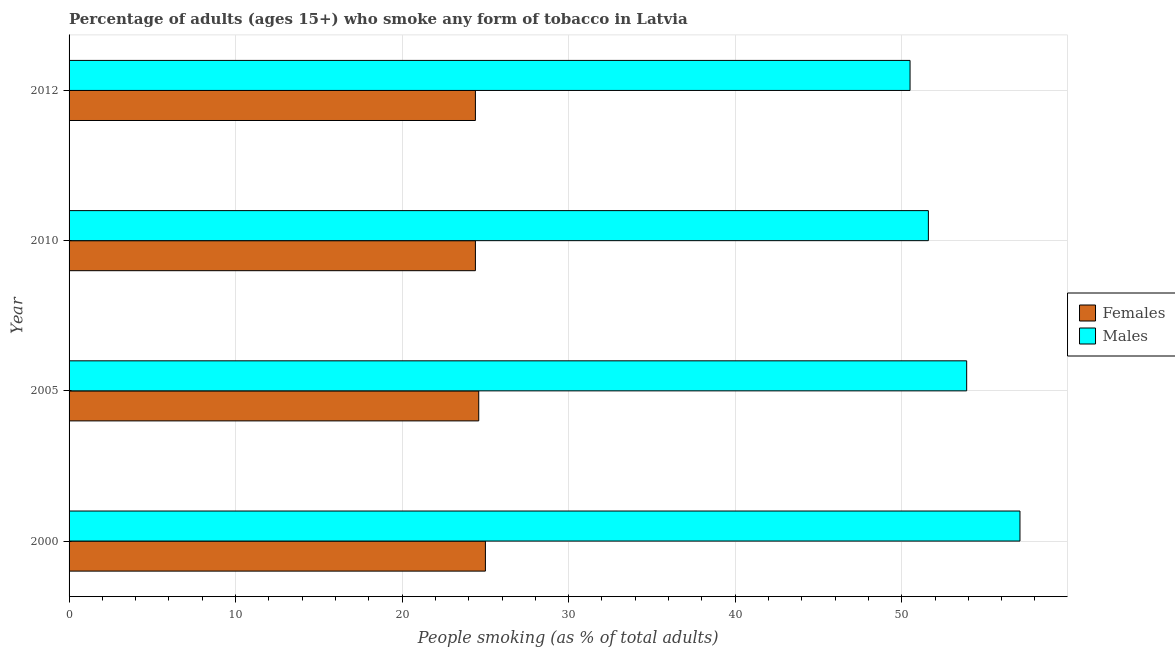How many groups of bars are there?
Your answer should be very brief. 4. Are the number of bars on each tick of the Y-axis equal?
Offer a terse response. Yes. How many bars are there on the 3rd tick from the bottom?
Keep it short and to the point. 2. What is the label of the 4th group of bars from the top?
Make the answer very short. 2000. In how many cases, is the number of bars for a given year not equal to the number of legend labels?
Your response must be concise. 0. What is the percentage of females who smoke in 2005?
Ensure brevity in your answer.  24.6. Across all years, what is the minimum percentage of males who smoke?
Make the answer very short. 50.5. In which year was the percentage of females who smoke maximum?
Your answer should be compact. 2000. In which year was the percentage of males who smoke minimum?
Offer a terse response. 2012. What is the total percentage of females who smoke in the graph?
Give a very brief answer. 98.4. What is the difference between the percentage of males who smoke in 2000 and the percentage of females who smoke in 2012?
Your answer should be compact. 32.7. What is the average percentage of females who smoke per year?
Provide a succinct answer. 24.6. In the year 2010, what is the difference between the percentage of females who smoke and percentage of males who smoke?
Your response must be concise. -27.2. What is the ratio of the percentage of males who smoke in 2000 to that in 2010?
Offer a terse response. 1.11. Is the percentage of females who smoke in 2000 less than that in 2010?
Provide a succinct answer. No. Is the difference between the percentage of males who smoke in 2000 and 2010 greater than the difference between the percentage of females who smoke in 2000 and 2010?
Offer a very short reply. Yes. What is the difference between the highest and the second highest percentage of males who smoke?
Offer a terse response. 3.2. Is the sum of the percentage of females who smoke in 2005 and 2012 greater than the maximum percentage of males who smoke across all years?
Give a very brief answer. No. What does the 1st bar from the top in 2010 represents?
Keep it short and to the point. Males. What does the 1st bar from the bottom in 2005 represents?
Keep it short and to the point. Females. How many years are there in the graph?
Provide a short and direct response. 4. Where does the legend appear in the graph?
Provide a short and direct response. Center right. How many legend labels are there?
Offer a terse response. 2. How are the legend labels stacked?
Offer a very short reply. Vertical. What is the title of the graph?
Offer a terse response. Percentage of adults (ages 15+) who smoke any form of tobacco in Latvia. Does "Excluding technical cooperation" appear as one of the legend labels in the graph?
Your answer should be very brief. No. What is the label or title of the X-axis?
Offer a very short reply. People smoking (as % of total adults). What is the label or title of the Y-axis?
Your answer should be compact. Year. What is the People smoking (as % of total adults) of Females in 2000?
Ensure brevity in your answer.  25. What is the People smoking (as % of total adults) of Males in 2000?
Keep it short and to the point. 57.1. What is the People smoking (as % of total adults) in Females in 2005?
Your answer should be compact. 24.6. What is the People smoking (as % of total adults) of Males in 2005?
Provide a succinct answer. 53.9. What is the People smoking (as % of total adults) in Females in 2010?
Your response must be concise. 24.4. What is the People smoking (as % of total adults) of Males in 2010?
Ensure brevity in your answer.  51.6. What is the People smoking (as % of total adults) in Females in 2012?
Ensure brevity in your answer.  24.4. What is the People smoking (as % of total adults) of Males in 2012?
Your response must be concise. 50.5. Across all years, what is the maximum People smoking (as % of total adults) of Females?
Provide a succinct answer. 25. Across all years, what is the maximum People smoking (as % of total adults) of Males?
Provide a short and direct response. 57.1. Across all years, what is the minimum People smoking (as % of total adults) of Females?
Your answer should be very brief. 24.4. Across all years, what is the minimum People smoking (as % of total adults) in Males?
Provide a succinct answer. 50.5. What is the total People smoking (as % of total adults) in Females in the graph?
Keep it short and to the point. 98.4. What is the total People smoking (as % of total adults) of Males in the graph?
Your response must be concise. 213.1. What is the difference between the People smoking (as % of total adults) of Males in 2000 and that in 2005?
Offer a terse response. 3.2. What is the difference between the People smoking (as % of total adults) of Females in 2000 and that in 2012?
Ensure brevity in your answer.  0.6. What is the difference between the People smoking (as % of total adults) in Males in 2000 and that in 2012?
Your answer should be compact. 6.6. What is the difference between the People smoking (as % of total adults) in Males in 2005 and that in 2010?
Give a very brief answer. 2.3. What is the difference between the People smoking (as % of total adults) of Females in 2005 and that in 2012?
Provide a short and direct response. 0.2. What is the difference between the People smoking (as % of total adults) of Females in 2010 and that in 2012?
Give a very brief answer. 0. What is the difference between the People smoking (as % of total adults) of Females in 2000 and the People smoking (as % of total adults) of Males in 2005?
Offer a very short reply. -28.9. What is the difference between the People smoking (as % of total adults) in Females in 2000 and the People smoking (as % of total adults) in Males in 2010?
Make the answer very short. -26.6. What is the difference between the People smoking (as % of total adults) of Females in 2000 and the People smoking (as % of total adults) of Males in 2012?
Your answer should be very brief. -25.5. What is the difference between the People smoking (as % of total adults) in Females in 2005 and the People smoking (as % of total adults) in Males in 2012?
Your answer should be compact. -25.9. What is the difference between the People smoking (as % of total adults) of Females in 2010 and the People smoking (as % of total adults) of Males in 2012?
Offer a very short reply. -26.1. What is the average People smoking (as % of total adults) in Females per year?
Your response must be concise. 24.6. What is the average People smoking (as % of total adults) in Males per year?
Your answer should be compact. 53.27. In the year 2000, what is the difference between the People smoking (as % of total adults) of Females and People smoking (as % of total adults) of Males?
Offer a very short reply. -32.1. In the year 2005, what is the difference between the People smoking (as % of total adults) of Females and People smoking (as % of total adults) of Males?
Offer a terse response. -29.3. In the year 2010, what is the difference between the People smoking (as % of total adults) in Females and People smoking (as % of total adults) in Males?
Offer a terse response. -27.2. In the year 2012, what is the difference between the People smoking (as % of total adults) in Females and People smoking (as % of total adults) in Males?
Keep it short and to the point. -26.1. What is the ratio of the People smoking (as % of total adults) in Females in 2000 to that in 2005?
Keep it short and to the point. 1.02. What is the ratio of the People smoking (as % of total adults) in Males in 2000 to that in 2005?
Give a very brief answer. 1.06. What is the ratio of the People smoking (as % of total adults) in Females in 2000 to that in 2010?
Provide a short and direct response. 1.02. What is the ratio of the People smoking (as % of total adults) in Males in 2000 to that in 2010?
Keep it short and to the point. 1.11. What is the ratio of the People smoking (as % of total adults) of Females in 2000 to that in 2012?
Keep it short and to the point. 1.02. What is the ratio of the People smoking (as % of total adults) of Males in 2000 to that in 2012?
Ensure brevity in your answer.  1.13. What is the ratio of the People smoking (as % of total adults) of Females in 2005 to that in 2010?
Keep it short and to the point. 1.01. What is the ratio of the People smoking (as % of total adults) in Males in 2005 to that in 2010?
Provide a short and direct response. 1.04. What is the ratio of the People smoking (as % of total adults) of Females in 2005 to that in 2012?
Your response must be concise. 1.01. What is the ratio of the People smoking (as % of total adults) of Males in 2005 to that in 2012?
Keep it short and to the point. 1.07. What is the ratio of the People smoking (as % of total adults) in Males in 2010 to that in 2012?
Offer a terse response. 1.02. What is the difference between the highest and the second highest People smoking (as % of total adults) of Females?
Give a very brief answer. 0.4. What is the difference between the highest and the second highest People smoking (as % of total adults) in Males?
Ensure brevity in your answer.  3.2. What is the difference between the highest and the lowest People smoking (as % of total adults) in Males?
Ensure brevity in your answer.  6.6. 